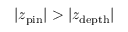<formula> <loc_0><loc_0><loc_500><loc_500>| z _ { p i n } | > | z _ { d e p t h } |</formula> 